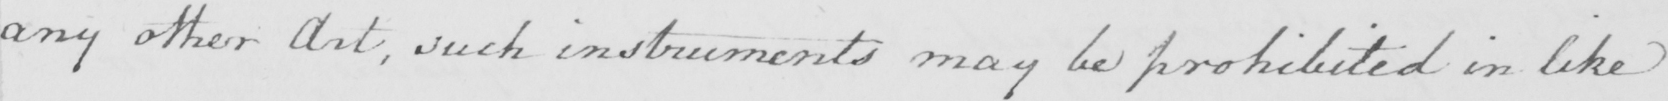Can you tell me what this handwritten text says? any other Art , such instruments may be prohibited in like 